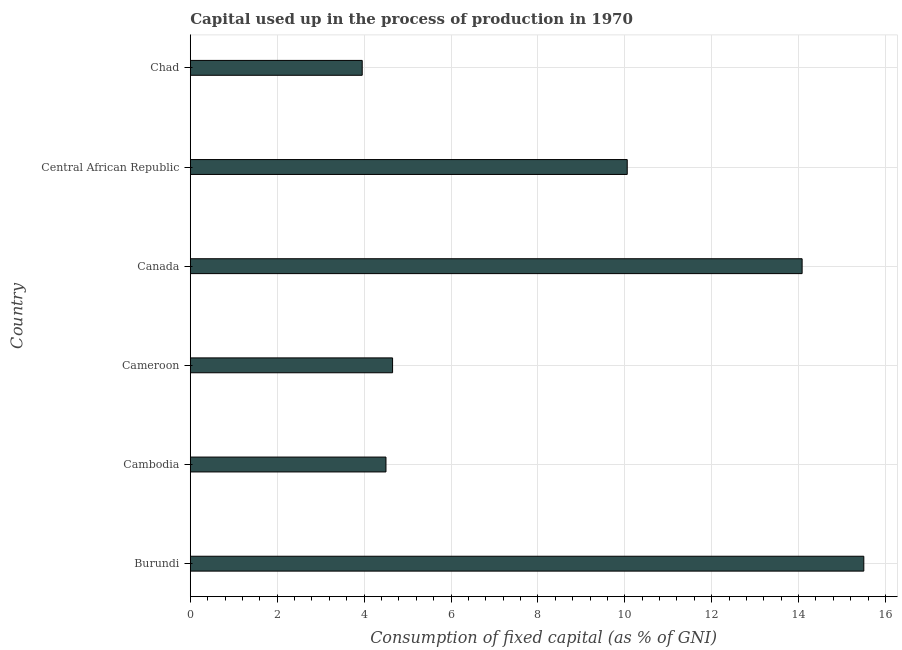Does the graph contain grids?
Offer a terse response. Yes. What is the title of the graph?
Ensure brevity in your answer.  Capital used up in the process of production in 1970. What is the label or title of the X-axis?
Offer a very short reply. Consumption of fixed capital (as % of GNI). What is the label or title of the Y-axis?
Your answer should be compact. Country. What is the consumption of fixed capital in Canada?
Provide a succinct answer. 14.08. Across all countries, what is the maximum consumption of fixed capital?
Your response must be concise. 15.5. Across all countries, what is the minimum consumption of fixed capital?
Provide a short and direct response. 3.96. In which country was the consumption of fixed capital maximum?
Your response must be concise. Burundi. In which country was the consumption of fixed capital minimum?
Your response must be concise. Chad. What is the sum of the consumption of fixed capital?
Your response must be concise. 52.75. What is the difference between the consumption of fixed capital in Cambodia and Cameroon?
Your response must be concise. -0.15. What is the average consumption of fixed capital per country?
Give a very brief answer. 8.79. What is the median consumption of fixed capital?
Your response must be concise. 7.36. What is the ratio of the consumption of fixed capital in Central African Republic to that in Chad?
Keep it short and to the point. 2.54. Is the consumption of fixed capital in Cameroon less than that in Chad?
Give a very brief answer. No. Is the difference between the consumption of fixed capital in Burundi and Canada greater than the difference between any two countries?
Keep it short and to the point. No. What is the difference between the highest and the second highest consumption of fixed capital?
Ensure brevity in your answer.  1.42. What is the difference between the highest and the lowest consumption of fixed capital?
Offer a terse response. 11.54. How many bars are there?
Provide a succinct answer. 6. Are all the bars in the graph horizontal?
Give a very brief answer. Yes. Are the values on the major ticks of X-axis written in scientific E-notation?
Your answer should be compact. No. What is the Consumption of fixed capital (as % of GNI) in Burundi?
Keep it short and to the point. 15.5. What is the Consumption of fixed capital (as % of GNI) in Cambodia?
Your response must be concise. 4.5. What is the Consumption of fixed capital (as % of GNI) of Cameroon?
Provide a short and direct response. 4.66. What is the Consumption of fixed capital (as % of GNI) in Canada?
Provide a succinct answer. 14.08. What is the Consumption of fixed capital (as % of GNI) of Central African Republic?
Ensure brevity in your answer.  10.06. What is the Consumption of fixed capital (as % of GNI) in Chad?
Ensure brevity in your answer.  3.96. What is the difference between the Consumption of fixed capital (as % of GNI) in Burundi and Cambodia?
Offer a terse response. 11. What is the difference between the Consumption of fixed capital (as % of GNI) in Burundi and Cameroon?
Make the answer very short. 10.85. What is the difference between the Consumption of fixed capital (as % of GNI) in Burundi and Canada?
Provide a succinct answer. 1.42. What is the difference between the Consumption of fixed capital (as % of GNI) in Burundi and Central African Republic?
Give a very brief answer. 5.44. What is the difference between the Consumption of fixed capital (as % of GNI) in Burundi and Chad?
Your answer should be compact. 11.54. What is the difference between the Consumption of fixed capital (as % of GNI) in Cambodia and Cameroon?
Keep it short and to the point. -0.15. What is the difference between the Consumption of fixed capital (as % of GNI) in Cambodia and Canada?
Offer a very short reply. -9.58. What is the difference between the Consumption of fixed capital (as % of GNI) in Cambodia and Central African Republic?
Provide a succinct answer. -5.55. What is the difference between the Consumption of fixed capital (as % of GNI) in Cambodia and Chad?
Your answer should be compact. 0.55. What is the difference between the Consumption of fixed capital (as % of GNI) in Cameroon and Canada?
Offer a very short reply. -9.43. What is the difference between the Consumption of fixed capital (as % of GNI) in Cameroon and Central African Republic?
Provide a succinct answer. -5.4. What is the difference between the Consumption of fixed capital (as % of GNI) in Cameroon and Chad?
Give a very brief answer. 0.7. What is the difference between the Consumption of fixed capital (as % of GNI) in Canada and Central African Republic?
Make the answer very short. 4.02. What is the difference between the Consumption of fixed capital (as % of GNI) in Canada and Chad?
Give a very brief answer. 10.12. What is the difference between the Consumption of fixed capital (as % of GNI) in Central African Republic and Chad?
Provide a succinct answer. 6.1. What is the ratio of the Consumption of fixed capital (as % of GNI) in Burundi to that in Cambodia?
Your response must be concise. 3.44. What is the ratio of the Consumption of fixed capital (as % of GNI) in Burundi to that in Cameroon?
Provide a short and direct response. 3.33. What is the ratio of the Consumption of fixed capital (as % of GNI) in Burundi to that in Canada?
Offer a terse response. 1.1. What is the ratio of the Consumption of fixed capital (as % of GNI) in Burundi to that in Central African Republic?
Your answer should be compact. 1.54. What is the ratio of the Consumption of fixed capital (as % of GNI) in Burundi to that in Chad?
Ensure brevity in your answer.  3.92. What is the ratio of the Consumption of fixed capital (as % of GNI) in Cambodia to that in Cameroon?
Provide a succinct answer. 0.97. What is the ratio of the Consumption of fixed capital (as % of GNI) in Cambodia to that in Canada?
Your answer should be compact. 0.32. What is the ratio of the Consumption of fixed capital (as % of GNI) in Cambodia to that in Central African Republic?
Provide a short and direct response. 0.45. What is the ratio of the Consumption of fixed capital (as % of GNI) in Cambodia to that in Chad?
Provide a succinct answer. 1.14. What is the ratio of the Consumption of fixed capital (as % of GNI) in Cameroon to that in Canada?
Offer a terse response. 0.33. What is the ratio of the Consumption of fixed capital (as % of GNI) in Cameroon to that in Central African Republic?
Your answer should be very brief. 0.46. What is the ratio of the Consumption of fixed capital (as % of GNI) in Cameroon to that in Chad?
Ensure brevity in your answer.  1.18. What is the ratio of the Consumption of fixed capital (as % of GNI) in Canada to that in Central African Republic?
Offer a very short reply. 1.4. What is the ratio of the Consumption of fixed capital (as % of GNI) in Canada to that in Chad?
Your answer should be compact. 3.56. What is the ratio of the Consumption of fixed capital (as % of GNI) in Central African Republic to that in Chad?
Your answer should be very brief. 2.54. 